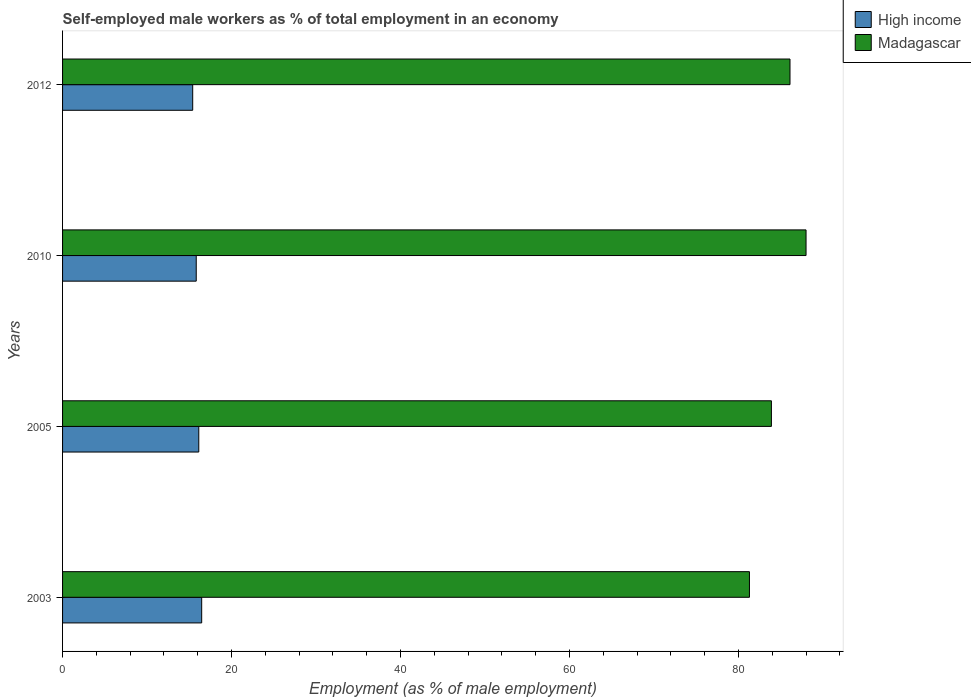What is the percentage of self-employed male workers in Madagascar in 2003?
Ensure brevity in your answer.  81.3. Across all years, what is the maximum percentage of self-employed male workers in Madagascar?
Make the answer very short. 88. Across all years, what is the minimum percentage of self-employed male workers in Madagascar?
Keep it short and to the point. 81.3. In which year was the percentage of self-employed male workers in Madagascar maximum?
Offer a very short reply. 2010. In which year was the percentage of self-employed male workers in High income minimum?
Provide a succinct answer. 2012. What is the total percentage of self-employed male workers in Madagascar in the graph?
Give a very brief answer. 339.3. What is the difference between the percentage of self-employed male workers in Madagascar in 2005 and that in 2010?
Your answer should be compact. -4.1. What is the difference between the percentage of self-employed male workers in Madagascar in 2005 and the percentage of self-employed male workers in High income in 2012?
Your answer should be compact. 68.5. What is the average percentage of self-employed male workers in High income per year?
Give a very brief answer. 15.95. In the year 2003, what is the difference between the percentage of self-employed male workers in High income and percentage of self-employed male workers in Madagascar?
Provide a short and direct response. -64.83. What is the ratio of the percentage of self-employed male workers in High income in 2005 to that in 2012?
Your answer should be very brief. 1.05. Is the percentage of self-employed male workers in Madagascar in 2003 less than that in 2012?
Ensure brevity in your answer.  Yes. Is the difference between the percentage of self-employed male workers in High income in 2005 and 2010 greater than the difference between the percentage of self-employed male workers in Madagascar in 2005 and 2010?
Provide a short and direct response. Yes. What is the difference between the highest and the second highest percentage of self-employed male workers in Madagascar?
Provide a succinct answer. 1.9. What is the difference between the highest and the lowest percentage of self-employed male workers in High income?
Ensure brevity in your answer.  1.06. Is the sum of the percentage of self-employed male workers in Madagascar in 2010 and 2012 greater than the maximum percentage of self-employed male workers in High income across all years?
Your answer should be compact. Yes. How many bars are there?
Offer a terse response. 8. Are all the bars in the graph horizontal?
Ensure brevity in your answer.  Yes. How many years are there in the graph?
Offer a terse response. 4. Are the values on the major ticks of X-axis written in scientific E-notation?
Make the answer very short. No. How are the legend labels stacked?
Offer a very short reply. Vertical. What is the title of the graph?
Provide a succinct answer. Self-employed male workers as % of total employment in an economy. Does "Lithuania" appear as one of the legend labels in the graph?
Offer a very short reply. No. What is the label or title of the X-axis?
Your response must be concise. Employment (as % of male employment). What is the Employment (as % of male employment) of High income in 2003?
Give a very brief answer. 16.47. What is the Employment (as % of male employment) of Madagascar in 2003?
Provide a short and direct response. 81.3. What is the Employment (as % of male employment) of High income in 2005?
Provide a short and direct response. 16.12. What is the Employment (as % of male employment) in Madagascar in 2005?
Ensure brevity in your answer.  83.9. What is the Employment (as % of male employment) in High income in 2010?
Your answer should be very brief. 15.82. What is the Employment (as % of male employment) in Madagascar in 2010?
Provide a short and direct response. 88. What is the Employment (as % of male employment) in High income in 2012?
Make the answer very short. 15.4. What is the Employment (as % of male employment) of Madagascar in 2012?
Offer a terse response. 86.1. Across all years, what is the maximum Employment (as % of male employment) of High income?
Ensure brevity in your answer.  16.47. Across all years, what is the maximum Employment (as % of male employment) of Madagascar?
Make the answer very short. 88. Across all years, what is the minimum Employment (as % of male employment) in High income?
Give a very brief answer. 15.4. Across all years, what is the minimum Employment (as % of male employment) in Madagascar?
Your answer should be very brief. 81.3. What is the total Employment (as % of male employment) of High income in the graph?
Your answer should be compact. 63.81. What is the total Employment (as % of male employment) of Madagascar in the graph?
Provide a succinct answer. 339.3. What is the difference between the Employment (as % of male employment) of High income in 2003 and that in 2005?
Offer a very short reply. 0.34. What is the difference between the Employment (as % of male employment) of High income in 2003 and that in 2010?
Offer a very short reply. 0.64. What is the difference between the Employment (as % of male employment) in Madagascar in 2003 and that in 2010?
Ensure brevity in your answer.  -6.7. What is the difference between the Employment (as % of male employment) of High income in 2003 and that in 2012?
Offer a terse response. 1.06. What is the difference between the Employment (as % of male employment) in High income in 2005 and that in 2010?
Your answer should be compact. 0.3. What is the difference between the Employment (as % of male employment) of High income in 2005 and that in 2012?
Make the answer very short. 0.72. What is the difference between the Employment (as % of male employment) of Madagascar in 2005 and that in 2012?
Make the answer very short. -2.2. What is the difference between the Employment (as % of male employment) of High income in 2010 and that in 2012?
Your answer should be compact. 0.42. What is the difference between the Employment (as % of male employment) in High income in 2003 and the Employment (as % of male employment) in Madagascar in 2005?
Provide a succinct answer. -67.43. What is the difference between the Employment (as % of male employment) in High income in 2003 and the Employment (as % of male employment) in Madagascar in 2010?
Keep it short and to the point. -71.53. What is the difference between the Employment (as % of male employment) of High income in 2003 and the Employment (as % of male employment) of Madagascar in 2012?
Ensure brevity in your answer.  -69.63. What is the difference between the Employment (as % of male employment) of High income in 2005 and the Employment (as % of male employment) of Madagascar in 2010?
Provide a succinct answer. -71.88. What is the difference between the Employment (as % of male employment) of High income in 2005 and the Employment (as % of male employment) of Madagascar in 2012?
Your answer should be very brief. -69.98. What is the difference between the Employment (as % of male employment) in High income in 2010 and the Employment (as % of male employment) in Madagascar in 2012?
Make the answer very short. -70.28. What is the average Employment (as % of male employment) of High income per year?
Provide a short and direct response. 15.95. What is the average Employment (as % of male employment) in Madagascar per year?
Provide a short and direct response. 84.83. In the year 2003, what is the difference between the Employment (as % of male employment) in High income and Employment (as % of male employment) in Madagascar?
Offer a terse response. -64.83. In the year 2005, what is the difference between the Employment (as % of male employment) in High income and Employment (as % of male employment) in Madagascar?
Your answer should be very brief. -67.78. In the year 2010, what is the difference between the Employment (as % of male employment) in High income and Employment (as % of male employment) in Madagascar?
Offer a terse response. -72.18. In the year 2012, what is the difference between the Employment (as % of male employment) of High income and Employment (as % of male employment) of Madagascar?
Your response must be concise. -70.7. What is the ratio of the Employment (as % of male employment) in High income in 2003 to that in 2005?
Your answer should be compact. 1.02. What is the ratio of the Employment (as % of male employment) in High income in 2003 to that in 2010?
Your answer should be compact. 1.04. What is the ratio of the Employment (as % of male employment) in Madagascar in 2003 to that in 2010?
Keep it short and to the point. 0.92. What is the ratio of the Employment (as % of male employment) in High income in 2003 to that in 2012?
Offer a very short reply. 1.07. What is the ratio of the Employment (as % of male employment) of Madagascar in 2003 to that in 2012?
Ensure brevity in your answer.  0.94. What is the ratio of the Employment (as % of male employment) of High income in 2005 to that in 2010?
Keep it short and to the point. 1.02. What is the ratio of the Employment (as % of male employment) of Madagascar in 2005 to that in 2010?
Keep it short and to the point. 0.95. What is the ratio of the Employment (as % of male employment) of High income in 2005 to that in 2012?
Provide a short and direct response. 1.05. What is the ratio of the Employment (as % of male employment) in Madagascar in 2005 to that in 2012?
Your answer should be compact. 0.97. What is the ratio of the Employment (as % of male employment) in High income in 2010 to that in 2012?
Ensure brevity in your answer.  1.03. What is the ratio of the Employment (as % of male employment) in Madagascar in 2010 to that in 2012?
Your answer should be compact. 1.02. What is the difference between the highest and the second highest Employment (as % of male employment) of High income?
Offer a terse response. 0.34. What is the difference between the highest and the lowest Employment (as % of male employment) in High income?
Your answer should be compact. 1.06. 